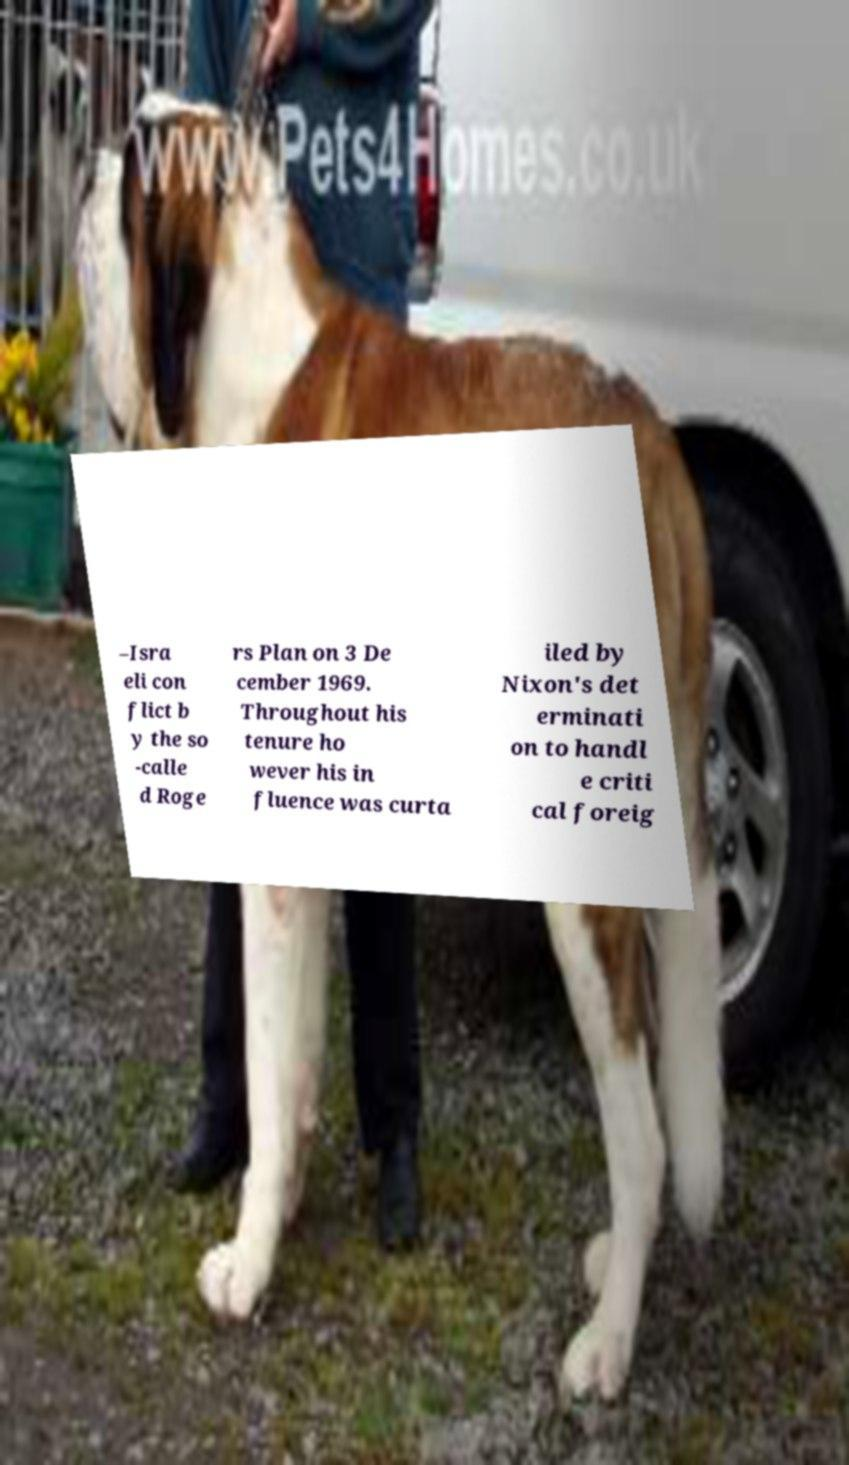Can you accurately transcribe the text from the provided image for me? –Isra eli con flict b y the so -calle d Roge rs Plan on 3 De cember 1969. Throughout his tenure ho wever his in fluence was curta iled by Nixon's det erminati on to handl e criti cal foreig 